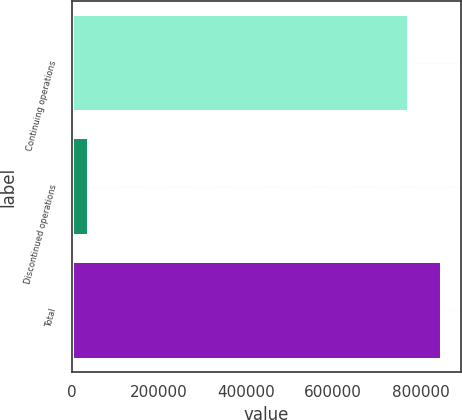Convert chart. <chart><loc_0><loc_0><loc_500><loc_500><bar_chart><fcel>Continuing operations<fcel>Discontinued operations<fcel>Total<nl><fcel>773134<fcel>39494<fcel>850447<nl></chart> 